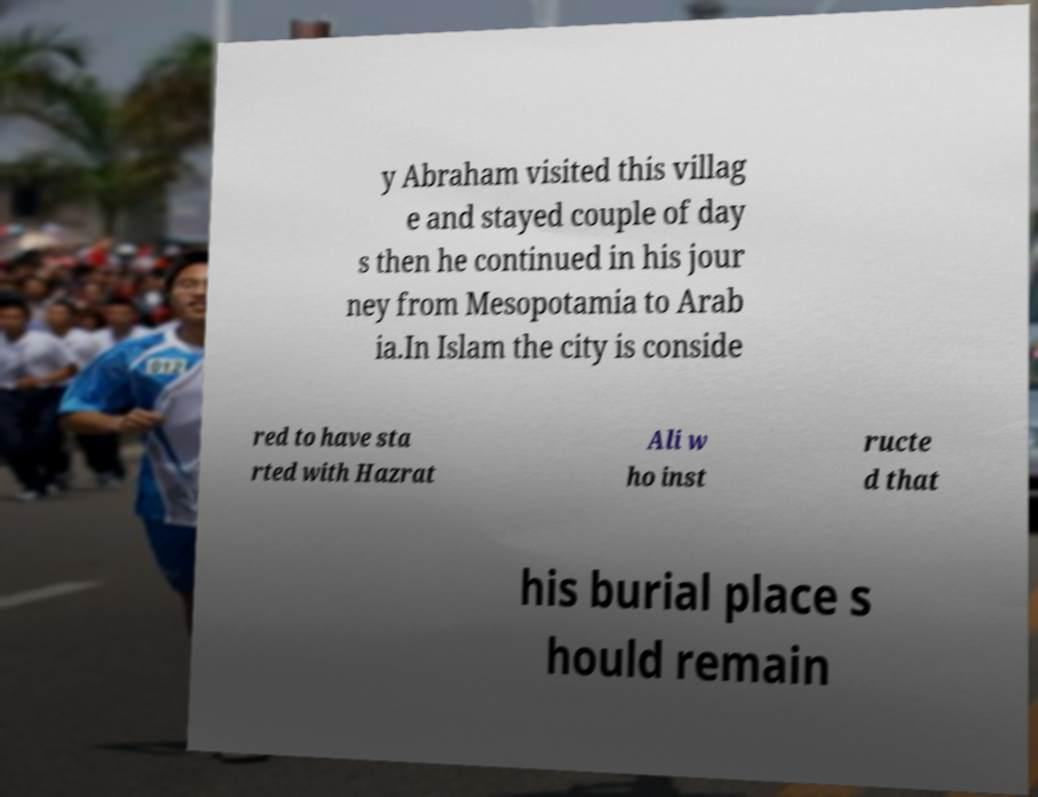What messages or text are displayed in this image? I need them in a readable, typed format. y Abraham visited this villag e and stayed couple of day s then he continued in his jour ney from Mesopotamia to Arab ia.In Islam the city is conside red to have sta rted with Hazrat Ali w ho inst ructe d that his burial place s hould remain 